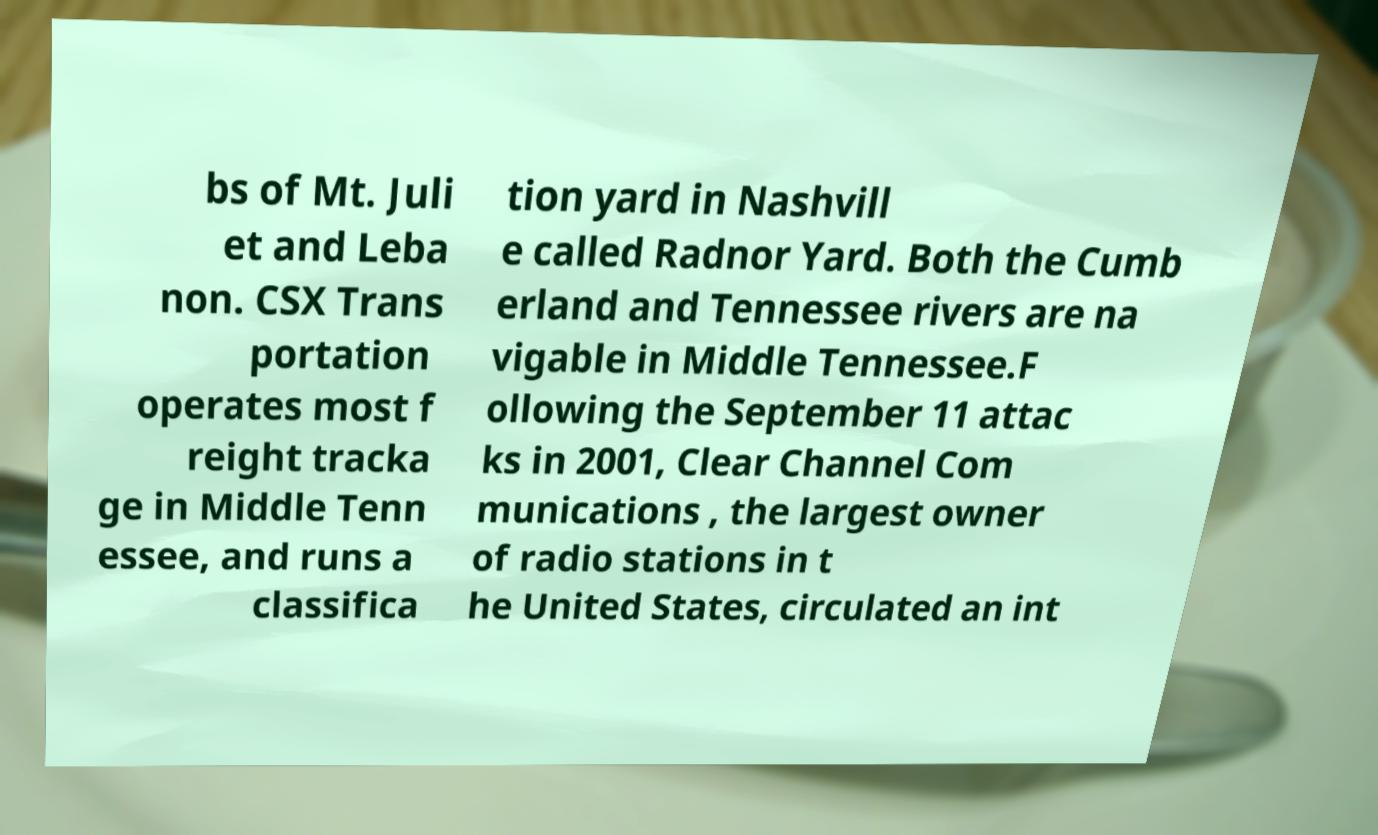Could you assist in decoding the text presented in this image and type it out clearly? bs of Mt. Juli et and Leba non. CSX Trans portation operates most f reight tracka ge in Middle Tenn essee, and runs a classifica tion yard in Nashvill e called Radnor Yard. Both the Cumb erland and Tennessee rivers are na vigable in Middle Tennessee.F ollowing the September 11 attac ks in 2001, Clear Channel Com munications , the largest owner of radio stations in t he United States, circulated an int 